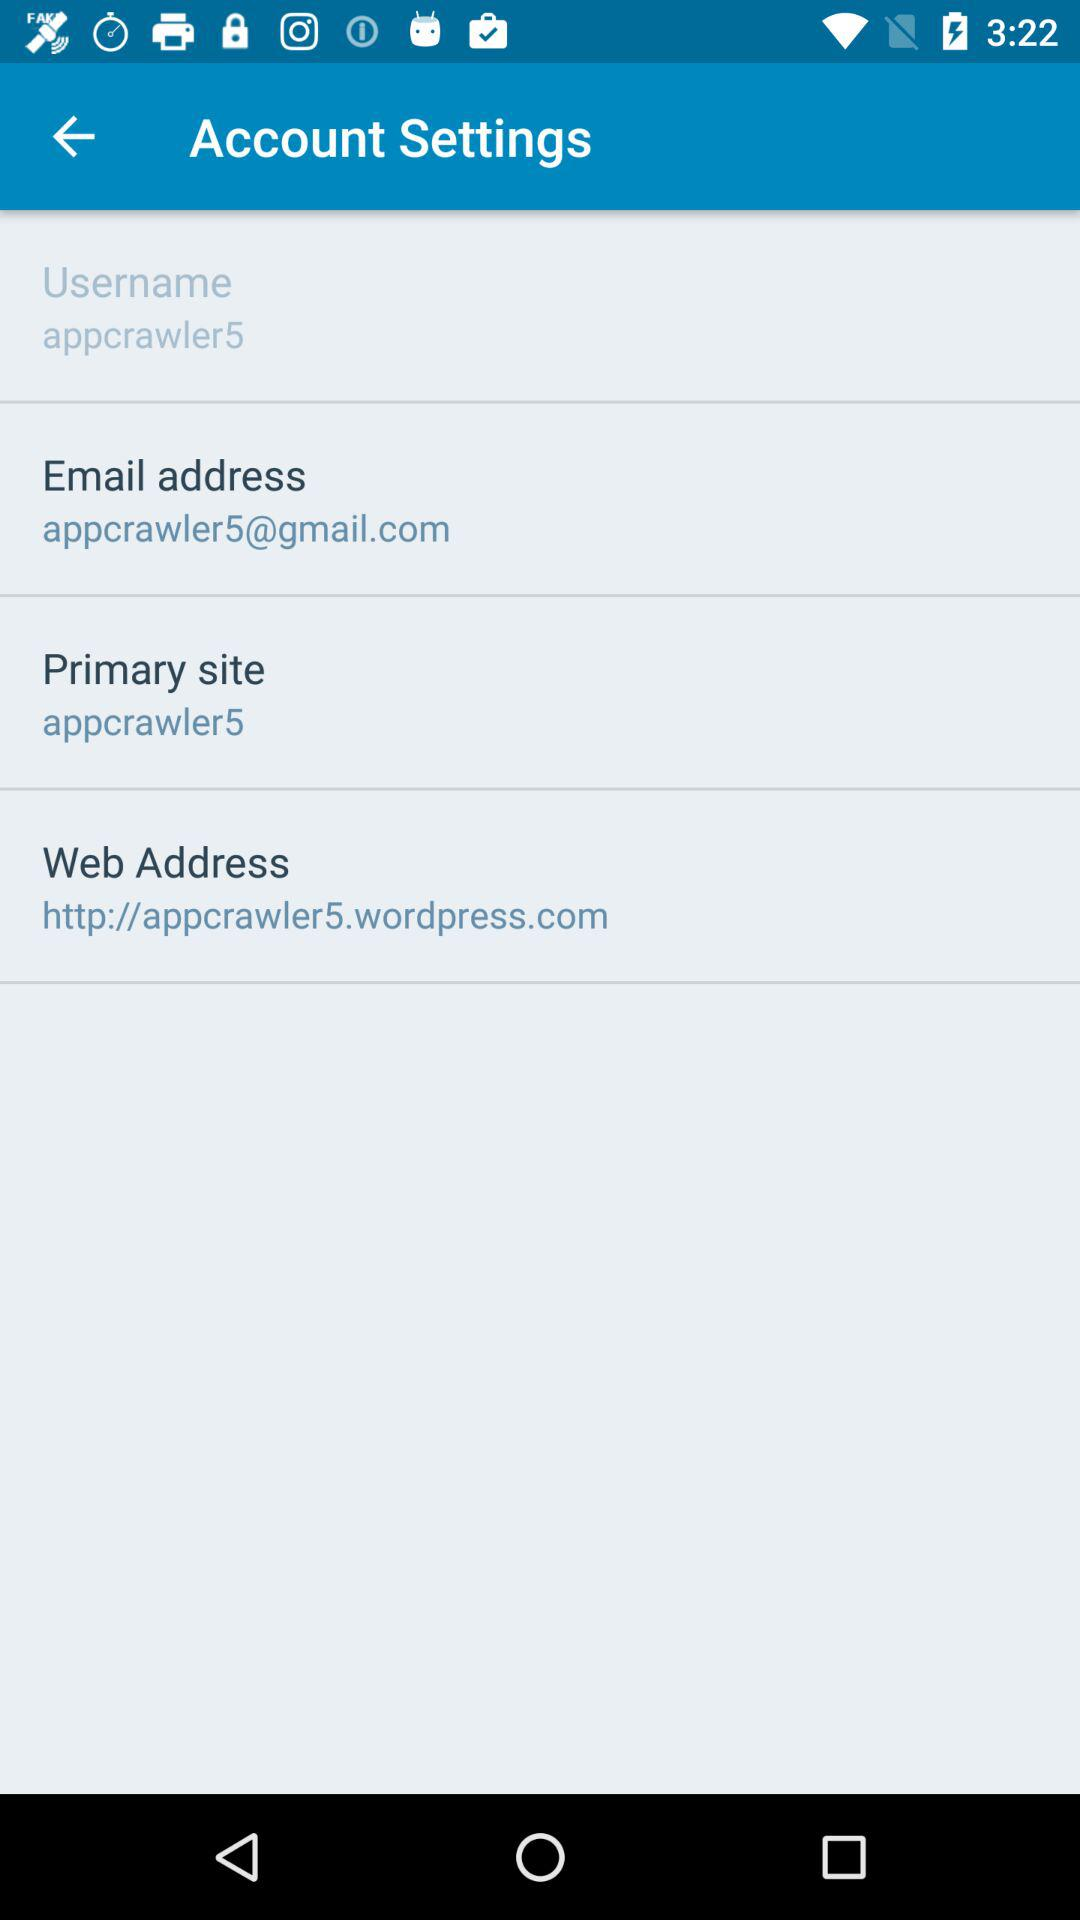What's the user profile name? The user profile name is "appcrawler5". 